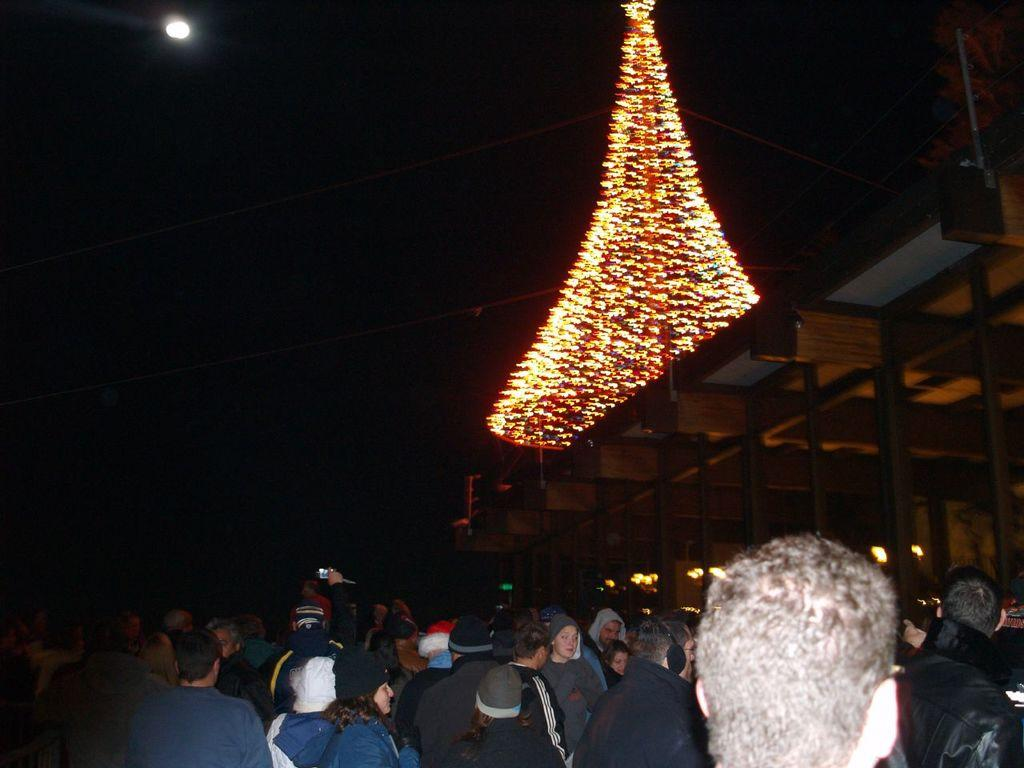What is the main feature of the image? There is a huge crowd in the image. What is in front of the crowd? There is a roof in front of the crowd. What can be seen above the roof? There are many lights arranged in the form of a cone above the roof. What is visible in the sky in the image? The sky is visible in the image, and there is a moon in the sky. What type of turkey is being prepared by the crowd in the image? There is no turkey present in the image, nor is there any indication that the crowd is preparing food. 